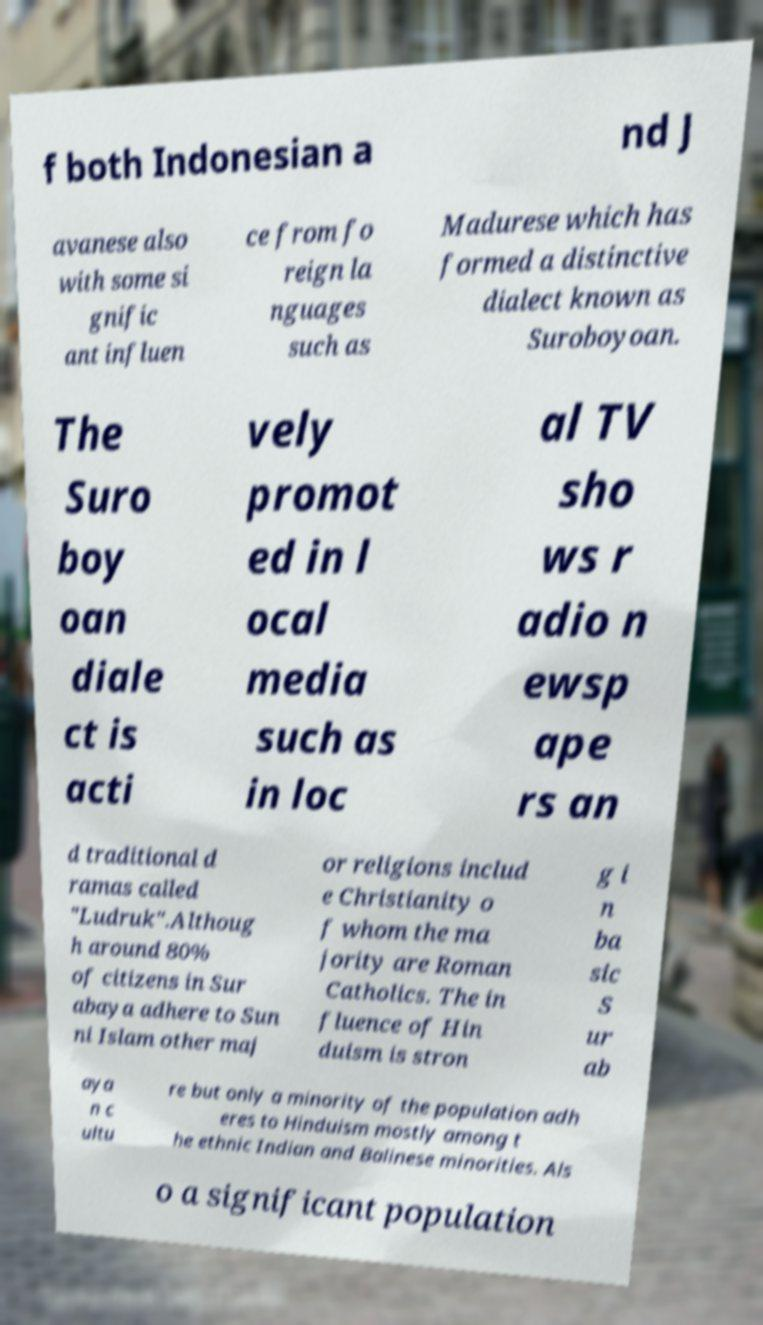Could you assist in decoding the text presented in this image and type it out clearly? f both Indonesian a nd J avanese also with some si gnific ant influen ce from fo reign la nguages such as Madurese which has formed a distinctive dialect known as Suroboyoan. The Suro boy oan diale ct is acti vely promot ed in l ocal media such as in loc al TV sho ws r adio n ewsp ape rs an d traditional d ramas called "Ludruk".Althoug h around 80% of citizens in Sur abaya adhere to Sun ni Islam other maj or religions includ e Christianity o f whom the ma jority are Roman Catholics. The in fluence of Hin duism is stron g i n ba sic S ur ab aya n c ultu re but only a minority of the population adh eres to Hinduism mostly among t he ethnic Indian and Balinese minorities. Als o a significant population 